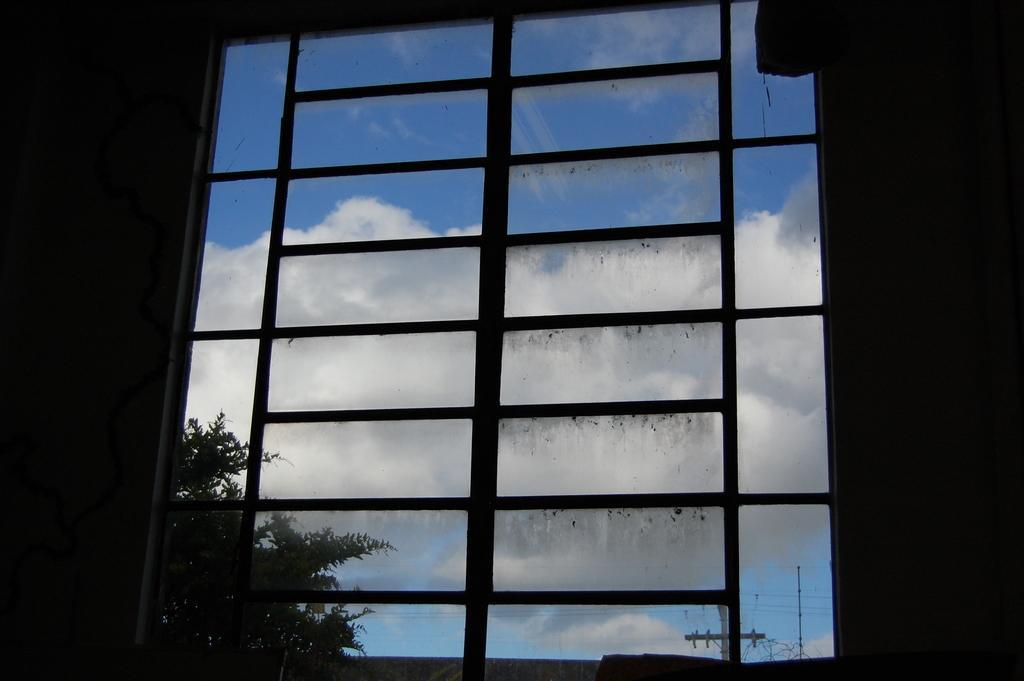Can you describe this image briefly? Here I can see a window through which we can see outside view. In the outside there are some trees and the poles. At the top I can see the sky and clouds. 